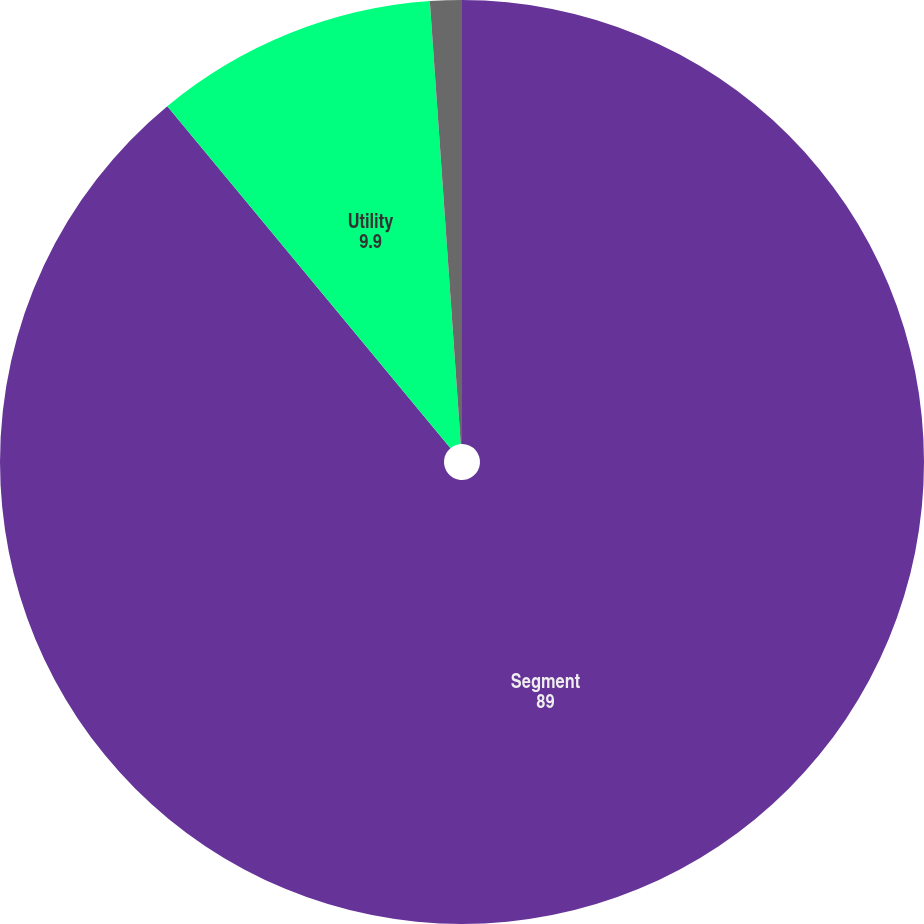<chart> <loc_0><loc_0><loc_500><loc_500><pie_chart><fcel>Segment<fcel>Utility<fcel>Entergy Wholesale Commodities<nl><fcel>89.0%<fcel>9.9%<fcel>1.11%<nl></chart> 